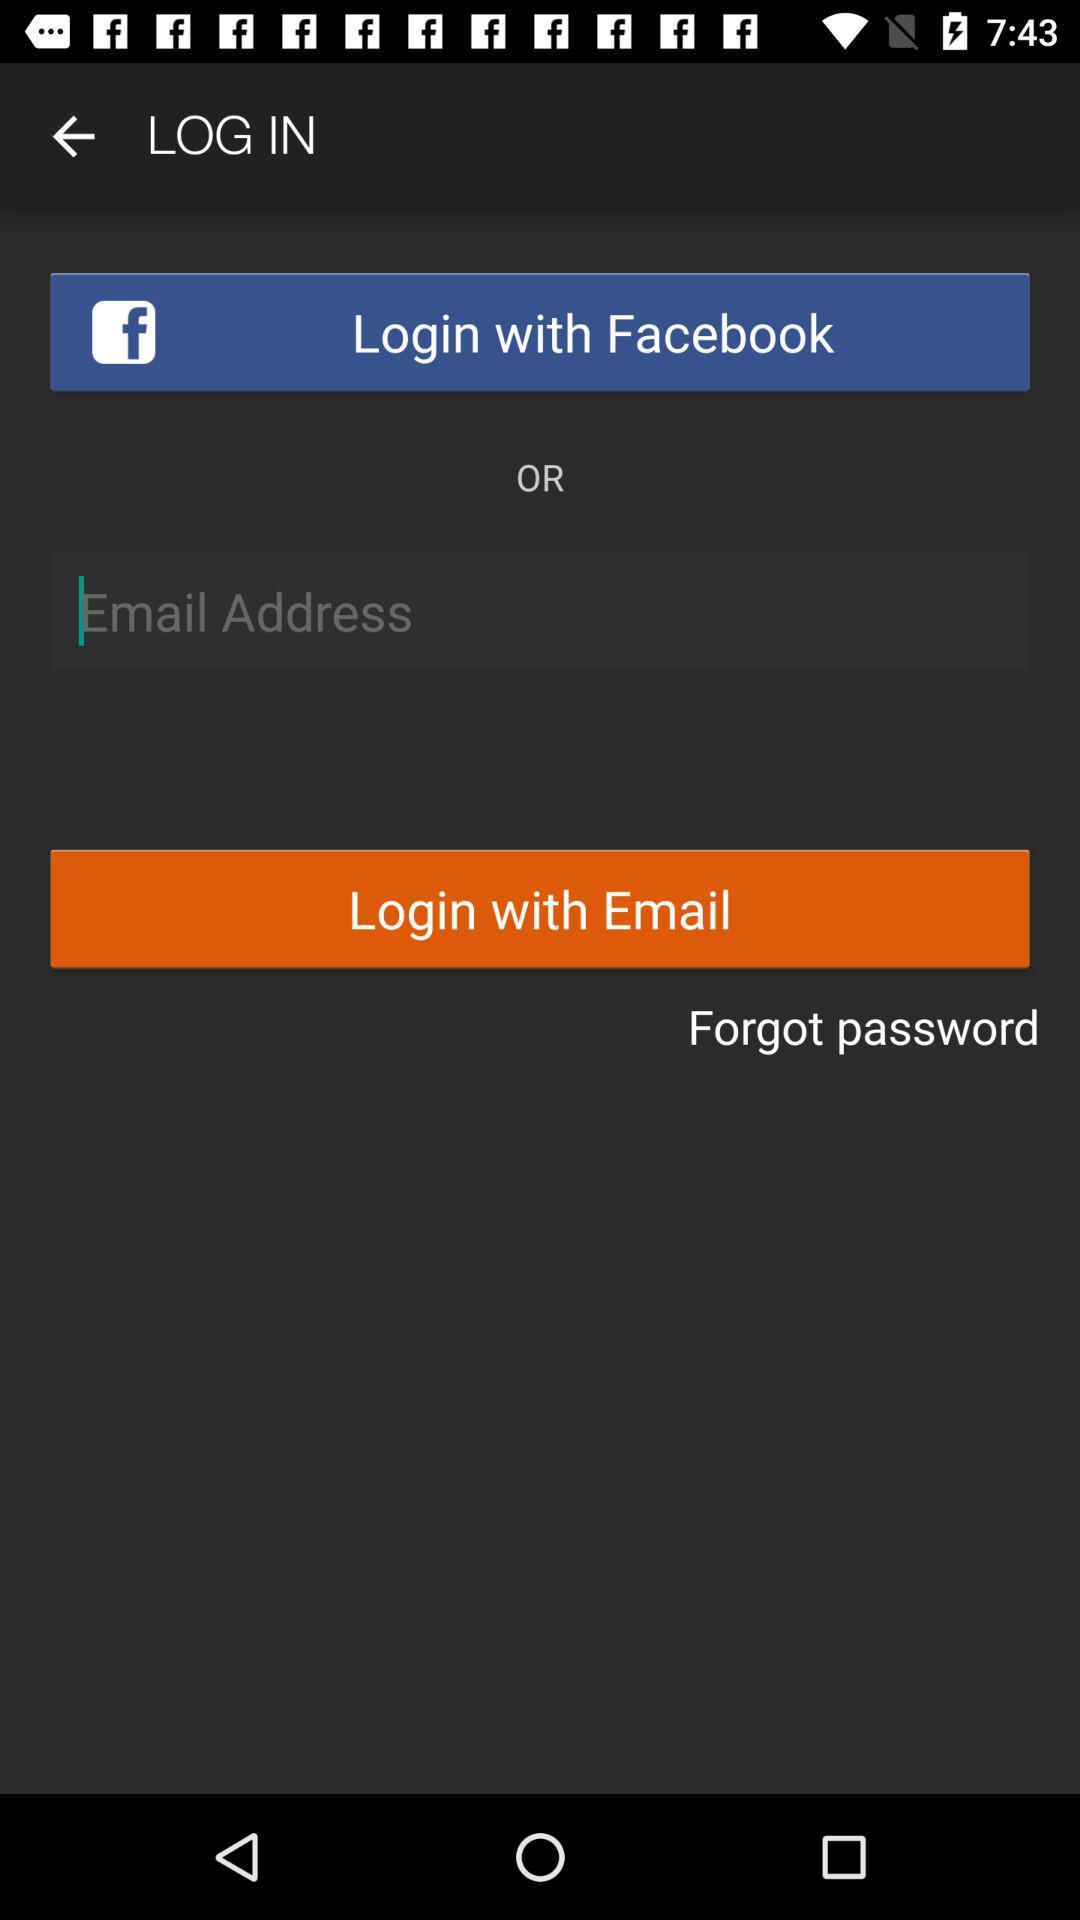How can we login? You can login with "Facebook" and "Email". 